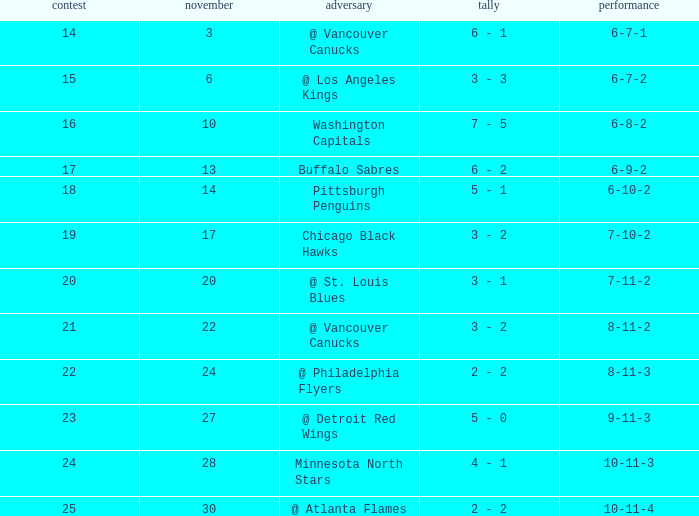Who is the opponent on november 24? @ Philadelphia Flyers. 